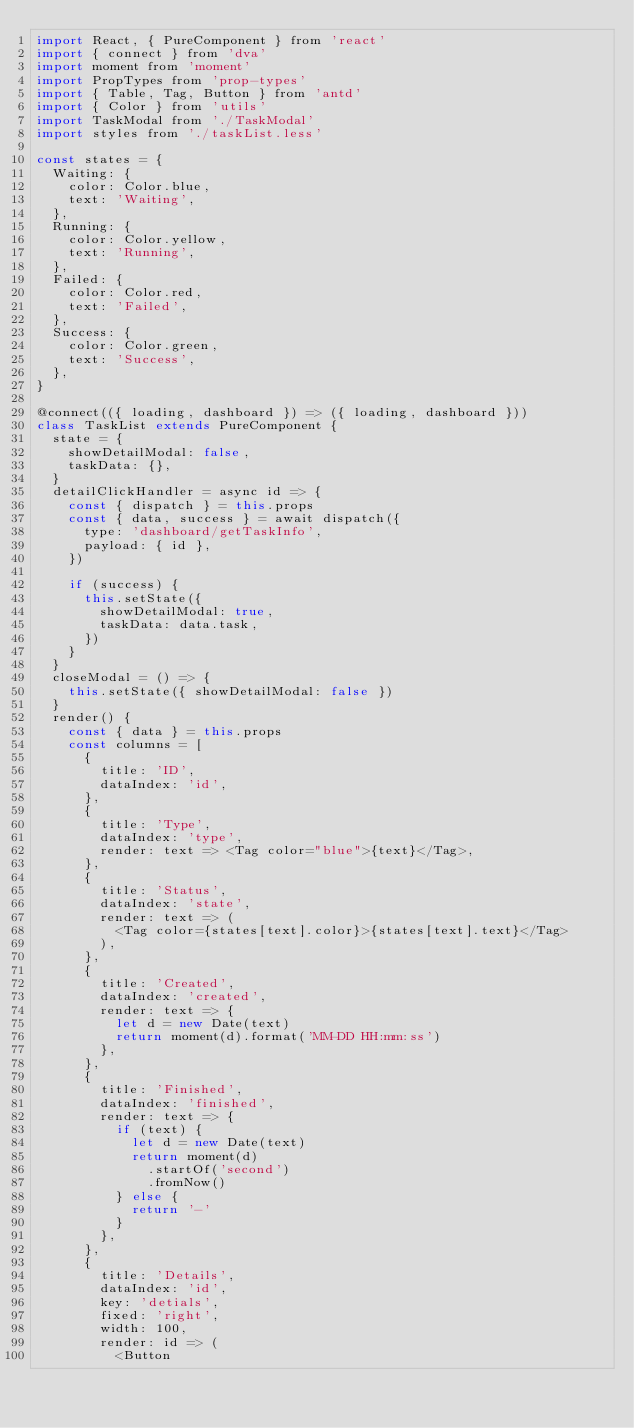Convert code to text. <code><loc_0><loc_0><loc_500><loc_500><_JavaScript_>import React, { PureComponent } from 'react'
import { connect } from 'dva'
import moment from 'moment'
import PropTypes from 'prop-types'
import { Table, Tag, Button } from 'antd'
import { Color } from 'utils'
import TaskModal from './TaskModal'
import styles from './taskList.less'

const states = {
  Waiting: {
    color: Color.blue,
    text: 'Waiting',
  },
  Running: {
    color: Color.yellow,
    text: 'Running',
  },
  Failed: {
    color: Color.red,
    text: 'Failed',
  },
  Success: {
    color: Color.green,
    text: 'Success',
  },
}

@connect(({ loading, dashboard }) => ({ loading, dashboard }))
class TaskList extends PureComponent {
  state = {
    showDetailModal: false,
    taskData: {},
  }
  detailClickHandler = async id => {
    const { dispatch } = this.props
    const { data, success } = await dispatch({
      type: 'dashboard/getTaskInfo',
      payload: { id },
    })

    if (success) {
      this.setState({
        showDetailModal: true,
        taskData: data.task,
      })
    }
  }
  closeModal = () => {
    this.setState({ showDetailModal: false })
  }
  render() {
    const { data } = this.props
    const columns = [
      {
        title: 'ID',
        dataIndex: 'id',
      },
      {
        title: 'Type',
        dataIndex: 'type',
        render: text => <Tag color="blue">{text}</Tag>,
      },
      {
        title: 'Status',
        dataIndex: 'state',
        render: text => (
          <Tag color={states[text].color}>{states[text].text}</Tag>
        ),
      },
      {
        title: 'Created',
        dataIndex: 'created',
        render: text => {
          let d = new Date(text)
          return moment(d).format('MM-DD HH:mm:ss')
        },
      },
      {
        title: 'Finished',
        dataIndex: 'finished',
        render: text => {
          if (text) {
            let d = new Date(text)
            return moment(d)
              .startOf('second')
              .fromNow()
          } else {
            return '-'
          }
        },
      },
      {
        title: 'Details',
        dataIndex: 'id',
        key: 'detials',
        fixed: 'right',
        width: 100,
        render: id => (
          <Button</code> 